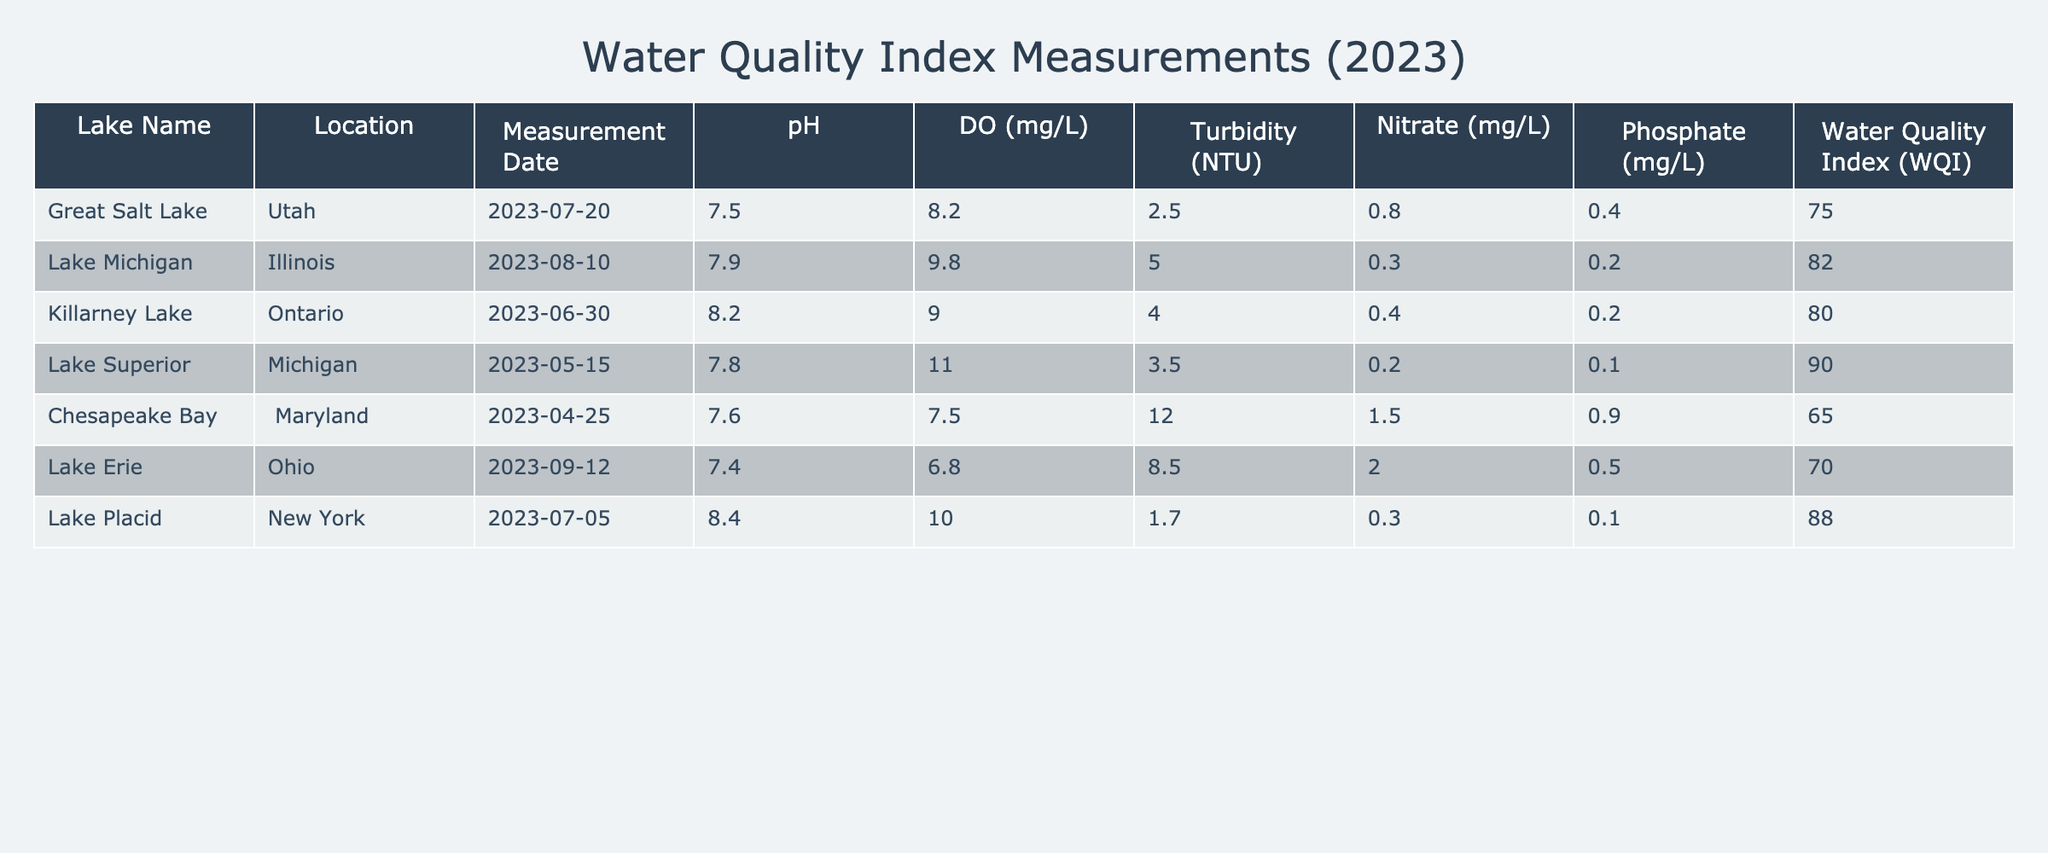What is the water quality index for Lake Michigan? The table shows a row for Lake Michigan. The Water Quality Index (WQI) is listed in that row as 82.
Answer: 82 Which lake has the highest pH value? The table lists pH values for each lake. Scanning the pH column, the highest value is 8.4 for Lake Placid.
Answer: Lake Placid Is the dissolved oxygen level in Chesapeake Bay greater than 7 mg/L? The dissolved oxygen level for Chesapeake Bay is specified as 7.5 mg/L, which is indeed greater than 7. Therefore, the answer is yes.
Answer: Yes What is the average turbidity of the lakes listed in the table? To find the average turbidity, sum the turbidity values: 2.5 + 5.0 + 4.0 + 3.5 + 12.0 + 8.5 + 1.7 = 37.2. There are 7 lakes, so the average turbidity is 37.2 / 7 = 5.31.
Answer: 5.31 Did any lake have a nitrate level higher than 1 mg/L? Looking through the nitrate values in the table, we see 0.8 for Great Salt Lake, 0.3 for Lake Michigan, 0.4 for Killarney Lake, 0.2 for Lake Superior, 1.5 for Chesapeake Bay, 2.0 for Lake Erie, and 0.3 for Lake Placid. Since Chesapeake Bay and Lake Erie both have nitrate levels higher than 1 mg/L, the answer is yes.
Answer: Yes What is the difference in water quality index between Lake Superior and Great Salt Lake? The WQI for Lake Superior is 90 and for Great Salt Lake it's 75. The difference is 90 - 75 = 15.
Answer: 15 Which location has the lowest overall water quality index? By reviewing the WQI values listed in the table, we find that Chesapeake Bay has the lowest WQI of 65.
Answer: Chesapeake Bay What is the total phosphate concentration of all the lakes? The phosphate levels are: 0.4 + 0.2 + 0.2 + 0.1 + 0.9 + 0.5 + 0.1 = 2.4 mg/L.
Answer: 2.4 mg/L Is Lake Erie the only location where turbidity is above 8 NTU? From the table, Lake Erie has a turbidity of 8.5 NTU. However, Chesapeake Bay has a turbidity of 12.0 NTU, which is also above 8 NTU. Therefore, the answer is no.
Answer: No 